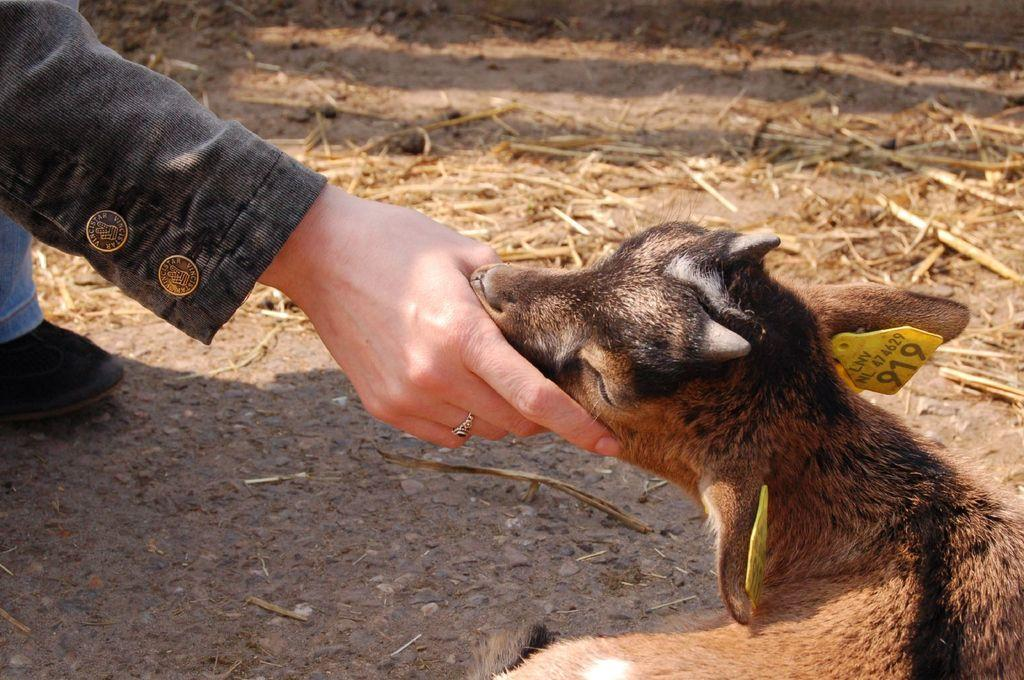What is located on the left side of the image? There is a person on the left side of the image. What is on the right side of the image? There is an animal on the right side of the image. What type of vegetation can be seen in the background of the image? There is grass visible in the background of the image. What type of toys can be seen in the image? There are no toys present in the image. Is there a volcano visible in the image? There is no volcano present in the image. 